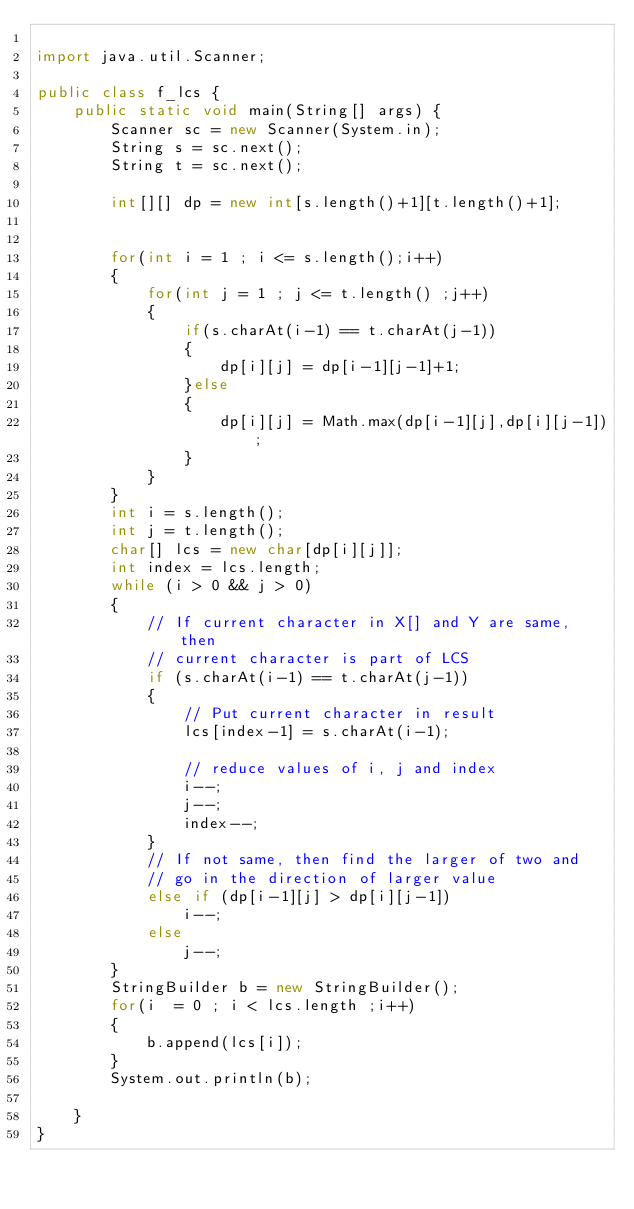Convert code to text. <code><loc_0><loc_0><loc_500><loc_500><_Java_>
import java.util.Scanner;

public class f_lcs {
    public static void main(String[] args) {
        Scanner sc = new Scanner(System.in);
        String s = sc.next();
        String t = sc.next();

        int[][] dp = new int[s.length()+1][t.length()+1];


        for(int i = 1 ; i <= s.length();i++)
        {
            for(int j = 1 ; j <= t.length() ;j++)
            {
                if(s.charAt(i-1) == t.charAt(j-1))
                {
                    dp[i][j] = dp[i-1][j-1]+1;
                }else
                {
                    dp[i][j] = Math.max(dp[i-1][j],dp[i][j-1]);
                }
            }
        }
        int i = s.length();
        int j = t.length();
        char[] lcs = new char[dp[i][j]];
        int index = lcs.length;
        while (i > 0 && j > 0)
        {
            // If current character in X[] and Y are same, then
            // current character is part of LCS
            if (s.charAt(i-1) == t.charAt(j-1))
            {
                // Put current character in result
                lcs[index-1] = s.charAt(i-1);

                // reduce values of i, j and index
                i--;
                j--;
                index--;
            }
            // If not same, then find the larger of two and
            // go in the direction of larger value
            else if (dp[i-1][j] > dp[i][j-1])
                i--;
            else
                j--;
        }
        StringBuilder b = new StringBuilder();
        for(i  = 0 ; i < lcs.length ;i++)
        {
            b.append(lcs[i]);
        }
        System.out.println(b);

    }
}
</code> 